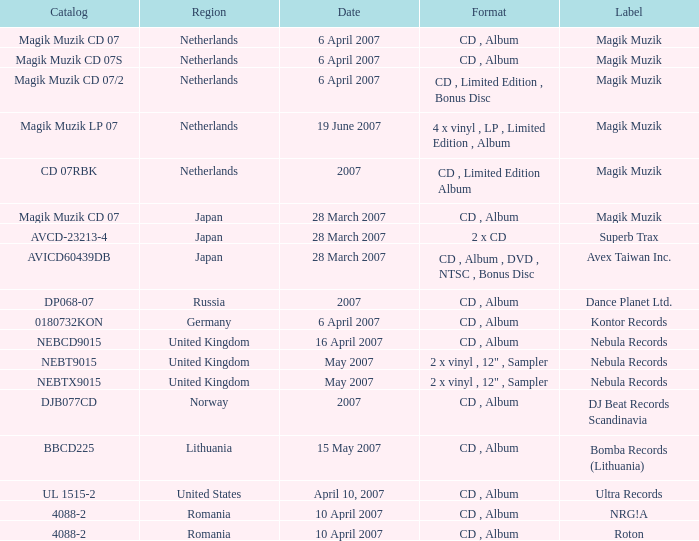From which region is the album with release date of 19 June 2007? Netherlands. 